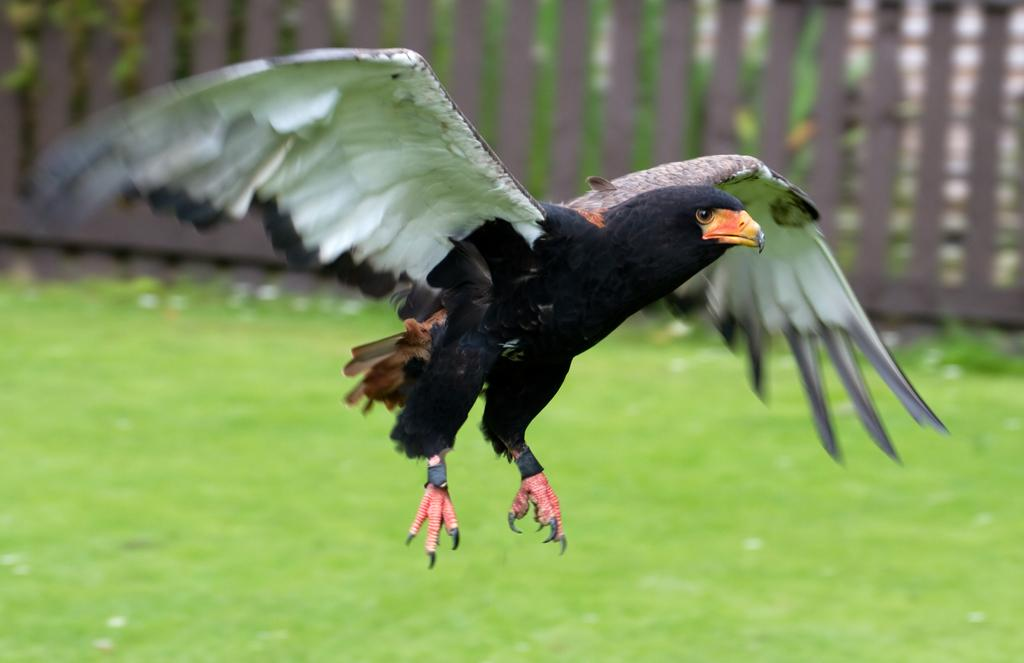What is the main subject of the image? There is an eagle flying in the image. Where is the eagle located in the image? The eagle is in the center of the image. What type of terrain is visible at the bottom of the image? There is grass at the bottom of the image. What can be seen in the background of the image? There are trees and a railing in the background of the image. What type of basket is being used to carry books in the image? There is no basket or books present in the image; it features an eagle flying in the center of the image. 